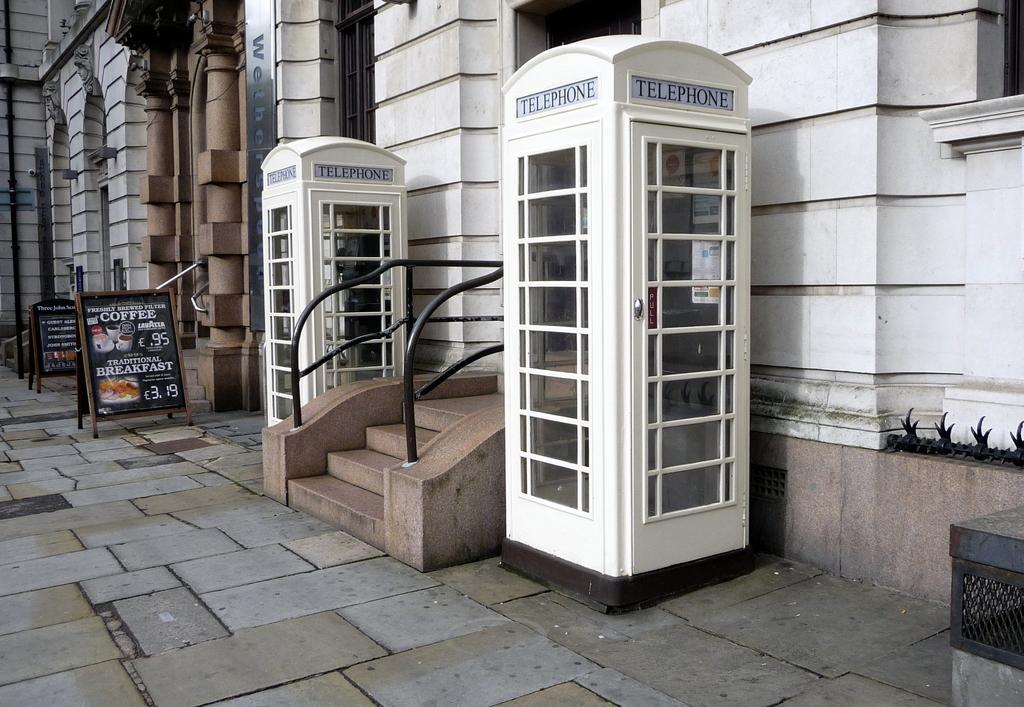What structures are located in the middle of the image? There are telephone booths and banners in the middle of the image. What can be seen in the background of the image? There is a building visible in the background of the image. How many pigs are crossing the bridge in the image? There are no pigs or bridge present in the image. What type of material is used to construct the brick wall in the image? There is no brick wall present in the image. 